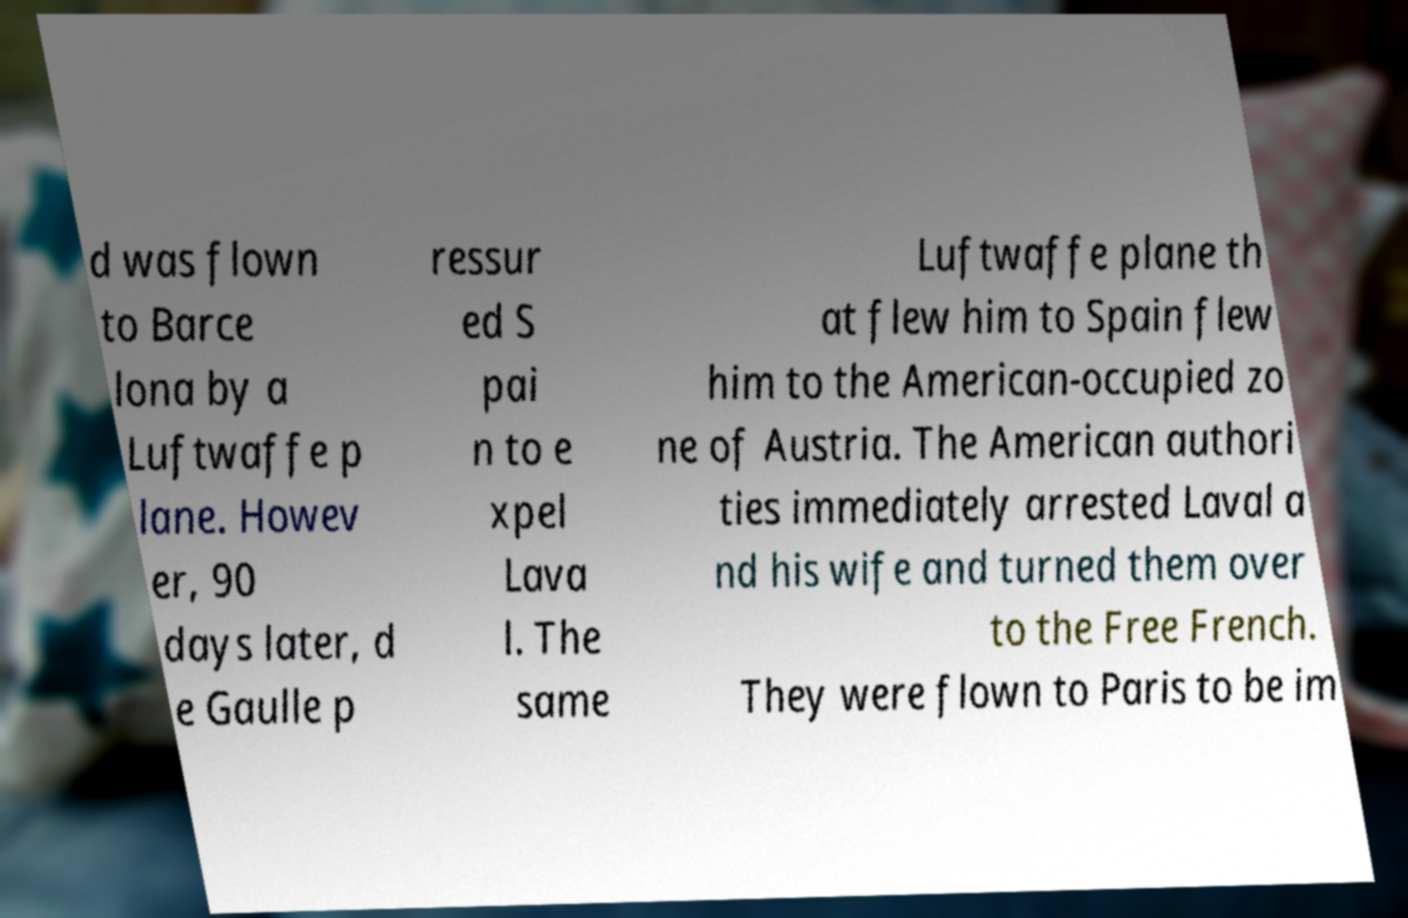Could you extract and type out the text from this image? d was flown to Barce lona by a Luftwaffe p lane. Howev er, 90 days later, d e Gaulle p ressur ed S pai n to e xpel Lava l. The same Luftwaffe plane th at flew him to Spain flew him to the American-occupied zo ne of Austria. The American authori ties immediately arrested Laval a nd his wife and turned them over to the Free French. They were flown to Paris to be im 